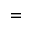Convert formula to latex. <formula><loc_0><loc_0><loc_500><loc_500>=</formula> 